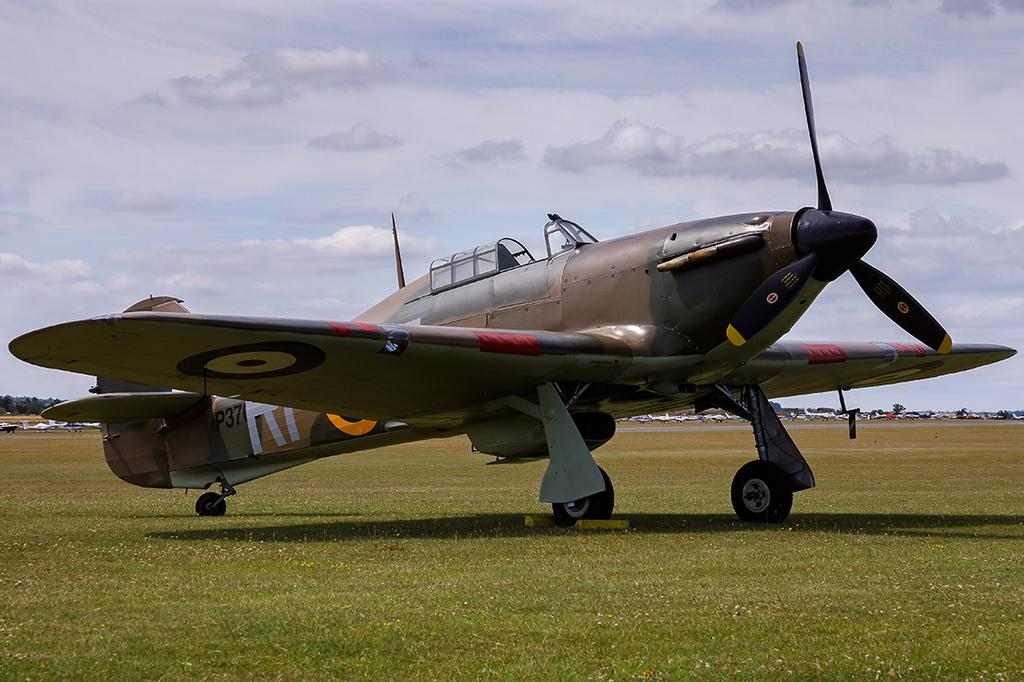What is the main subject in the center of the image? There is an aeroplane in the center of the image. What else can be seen in the background of the image? There are vehicles and the sky visible in the background of the image. What type of terrain is at the bottom of the image? There is grass at the bottom of the image. What is the opinion of the worm about the aeroplane in the image? There is no worm present in the image, so it is not possible to determine its opinion about the aeroplane. 